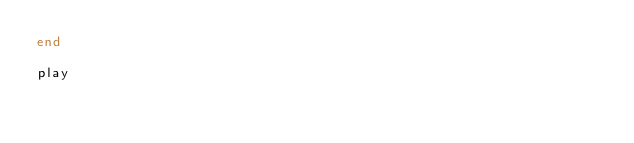<code> <loc_0><loc_0><loc_500><loc_500><_Ruby_>end

play

</code> 